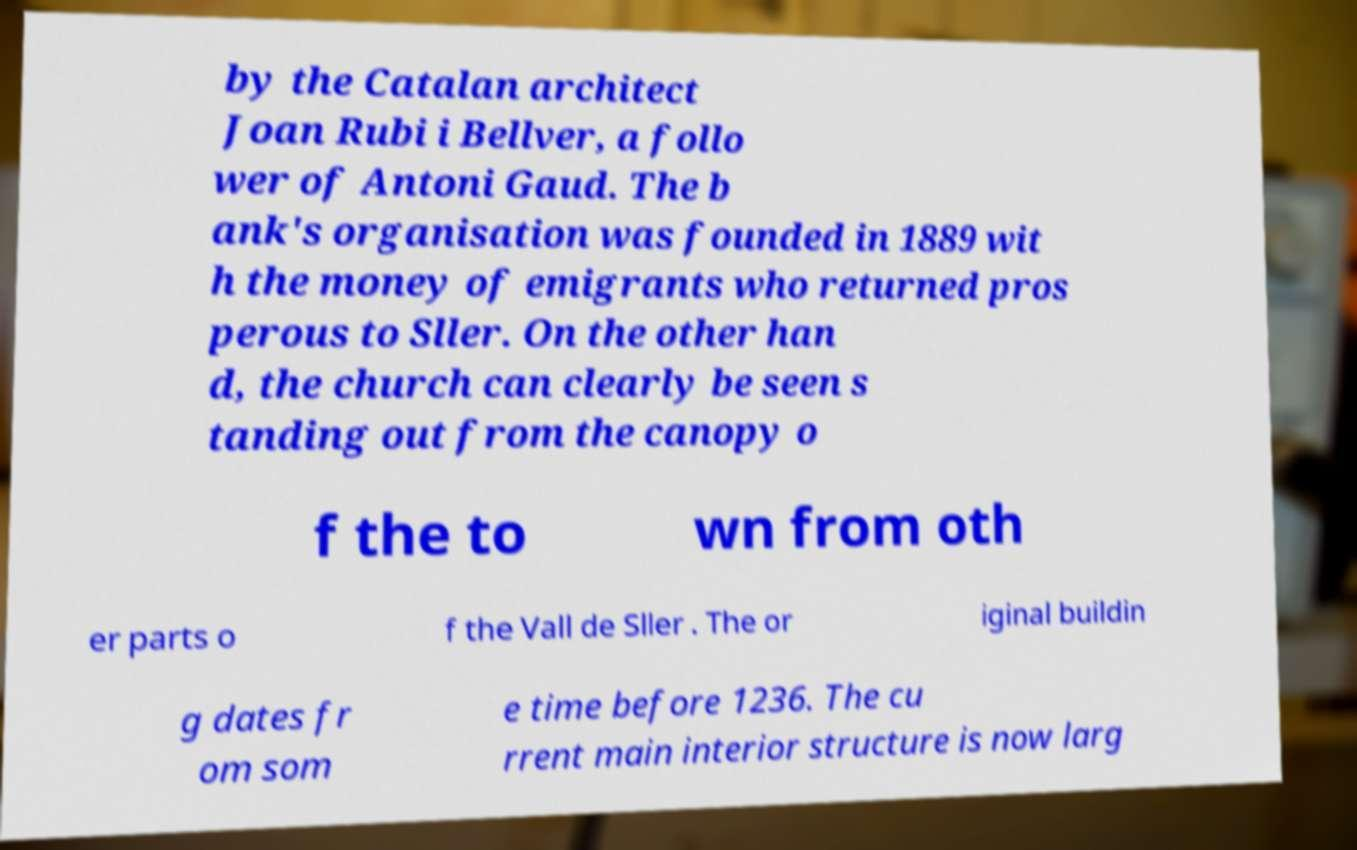I need the written content from this picture converted into text. Can you do that? by the Catalan architect Joan Rubi i Bellver, a follo wer of Antoni Gaud. The b ank's organisation was founded in 1889 wit h the money of emigrants who returned pros perous to Sller. On the other han d, the church can clearly be seen s tanding out from the canopy o f the to wn from oth er parts o f the Vall de Sller . The or iginal buildin g dates fr om som e time before 1236. The cu rrent main interior structure is now larg 